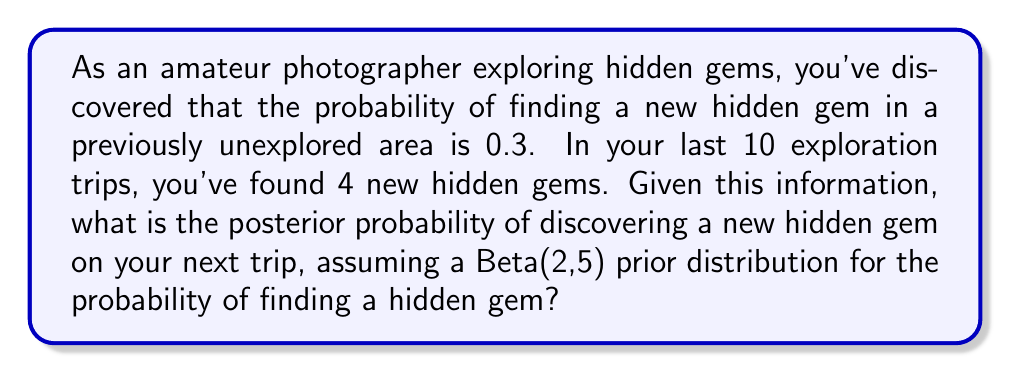Solve this math problem. To solve this problem, we'll use Bayesian inference with a Beta-Binomial model. The Beta distribution is conjugate to the Binomial distribution, making it ideal for this scenario.

1. Prior distribution: Beta(α, β) = Beta(2, 5)

2. Likelihood: Binomial(n, p), where n = 10 (total trips) and k = 4 (successes)

3. Posterior distribution: Beta(α + k, β + n - k)

Let's calculate the parameters of the posterior distribution:
* α_posterior = α + k = 2 + 4 = 6
* β_posterior = β + n - k = 5 + 10 - 4 = 11

The posterior distribution is therefore Beta(6, 11).

To find the probability of discovering a new hidden gem on the next trip, we need to calculate the expected value of this posterior distribution:

$$ E[Beta(α, β)] = \frac{\alpha}{\alpha + \beta} $$

Plugging in our values:

$$ E[Beta(6, 11)] = \frac{6}{6 + 11} = \frac{6}{17} \approx 0.3529 $$

This means that based on our prior beliefs and the observed data, the posterior probability of discovering a new hidden gem on the next trip is approximately 0.3529 or 35.29%.
Answer: The posterior probability of discovering a new hidden gem on the next trip is approximately 0.3529 or 35.29%. 